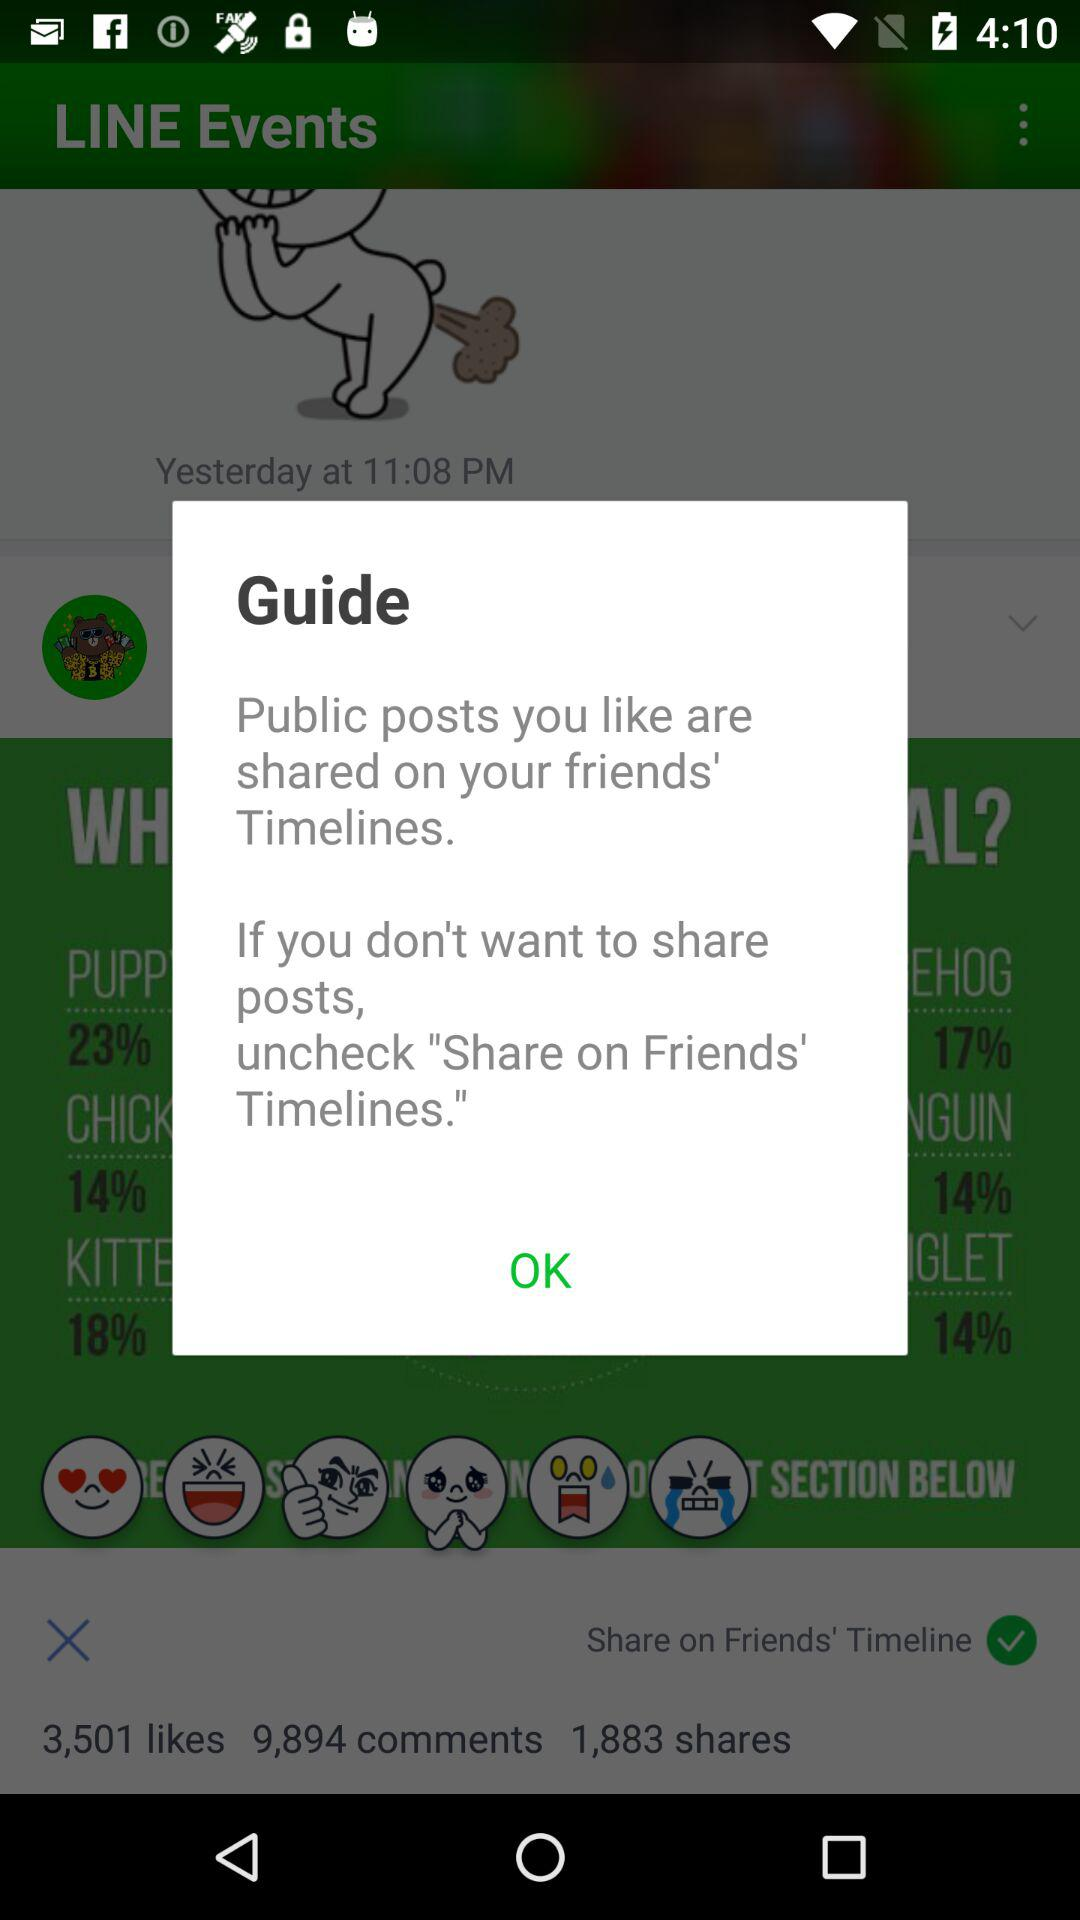What is the time? The time is 11:08 p.m. 